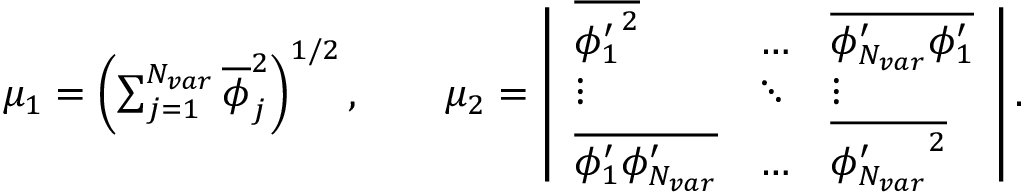<formula> <loc_0><loc_0><loc_500><loc_500>\begin{array} { r } { \mu _ { 1 } = \left ( \sum _ { j = 1 } ^ { N _ { v a r } } \overline { \phi } _ { j } ^ { 2 } \right ) ^ { 1 / 2 } , \quad m u _ { 2 } = \left | \begin{array} { l l l } { \overline { { { \phi _ { 1 } ^ { \prime } } ^ { 2 } } } } & { \dots } & { \overline { { \phi _ { N _ { v a r } } ^ { \prime } \phi _ { 1 } ^ { \prime } } } } \\ { \vdots } & { \ddots } & { \vdots } \\ { \overline { { \phi _ { 1 } ^ { \prime } \phi _ { N _ { v a r } } ^ { \prime } } } } & { \dots } & { \overline { { { \phi _ { N _ { v a r } } ^ { \prime } } ^ { 2 } } } } \end{array} \right | . } \end{array}</formula> 